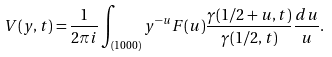Convert formula to latex. <formula><loc_0><loc_0><loc_500><loc_500>V ( y , t ) = \frac { 1 } { 2 \pi i } \int _ { ( 1 0 0 0 ) } y ^ { - u } F ( u ) \frac { \gamma ( { 1 } / { 2 } + u , t ) } { \gamma ( { 1 } / { 2 } , t ) } \frac { d u } { u } .</formula> 